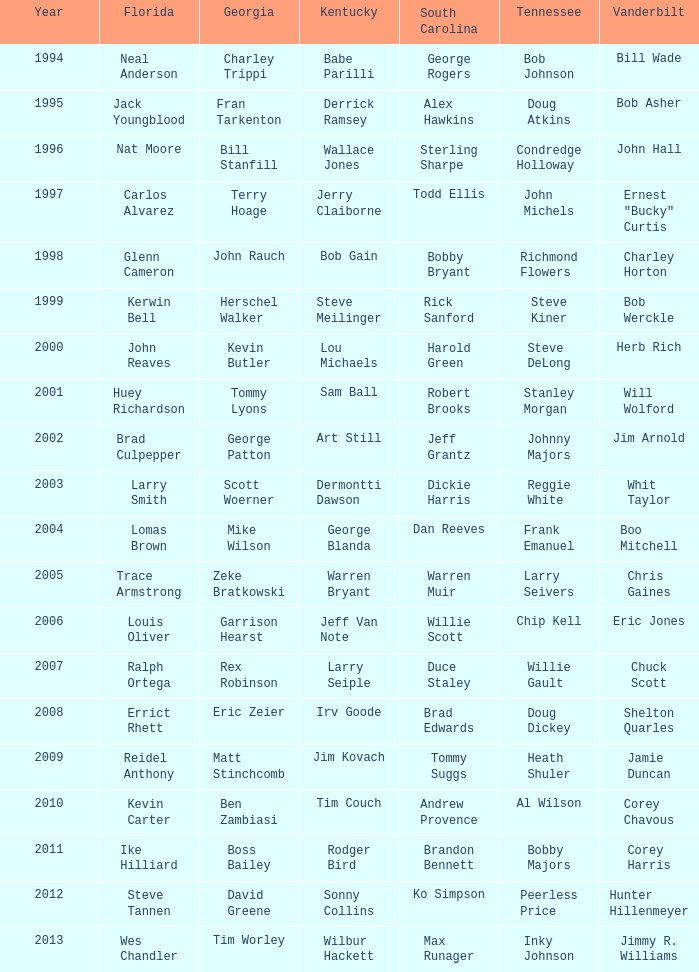What is the Tennessee that Georgia of kevin butler is in? Steve DeLong. 